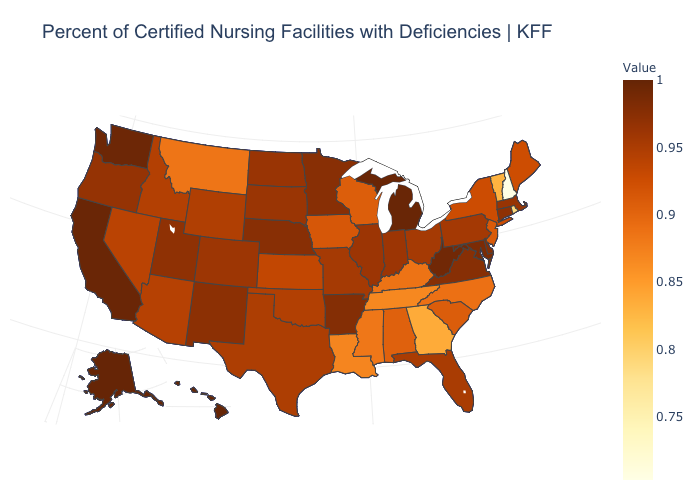Does Alaska have the highest value in the USA?
Quick response, please. Yes. Does the map have missing data?
Give a very brief answer. No. Does Alaska have the highest value in the USA?
Answer briefly. Yes. Does Colorado have the highest value in the West?
Be succinct. No. Does Alaska have the highest value in the West?
Quick response, please. Yes. Does Hawaii have the highest value in the USA?
Give a very brief answer. Yes. 